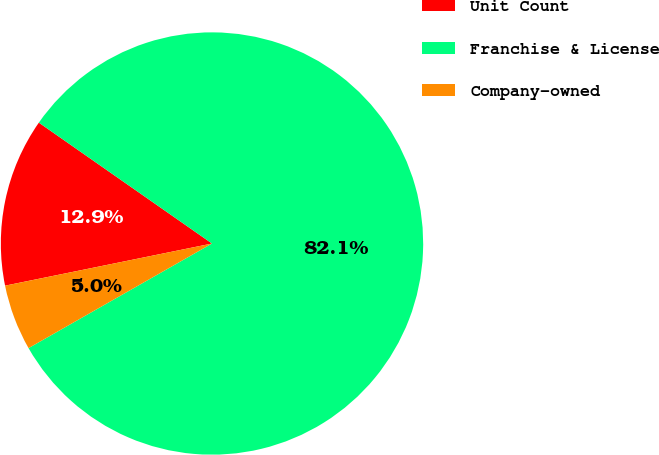Convert chart to OTSL. <chart><loc_0><loc_0><loc_500><loc_500><pie_chart><fcel>Unit Count<fcel>Franchise & License<fcel>Company-owned<nl><fcel>12.9%<fcel>82.06%<fcel>5.05%<nl></chart> 